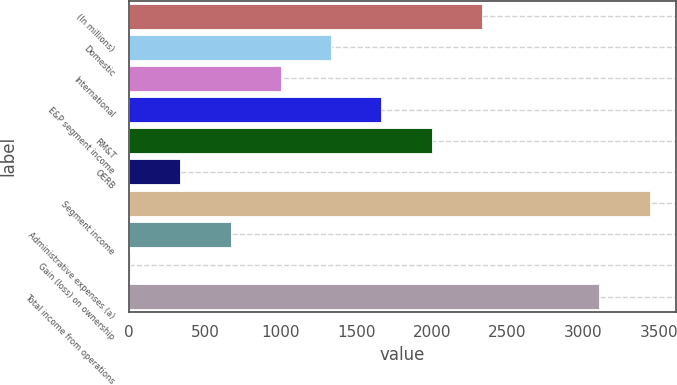<chart> <loc_0><loc_0><loc_500><loc_500><bar_chart><fcel>(In millions)<fcel>Domestic<fcel>International<fcel>E&P segment income<fcel>RM&T<fcel>OERB<fcel>Segment income<fcel>Administrative expenses (a)<fcel>Gain (loss) on ownership<fcel>Total income from operations<nl><fcel>2330.7<fcel>1334.4<fcel>1002.3<fcel>1666.5<fcel>1998.6<fcel>338.1<fcel>3440.1<fcel>670.2<fcel>6<fcel>3108<nl></chart> 